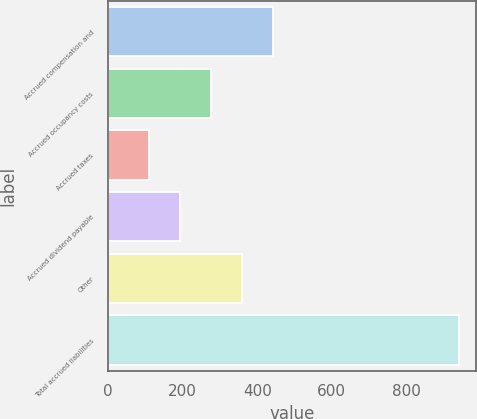Convert chart. <chart><loc_0><loc_0><loc_500><loc_500><bar_chart><fcel>Accrued compensation and<fcel>Accrued occupancy costs<fcel>Accrued taxes<fcel>Accrued dividend payable<fcel>Other<fcel>Total accrued liabilities<nl><fcel>441.88<fcel>275.54<fcel>109.2<fcel>192.37<fcel>358.71<fcel>940.9<nl></chart> 